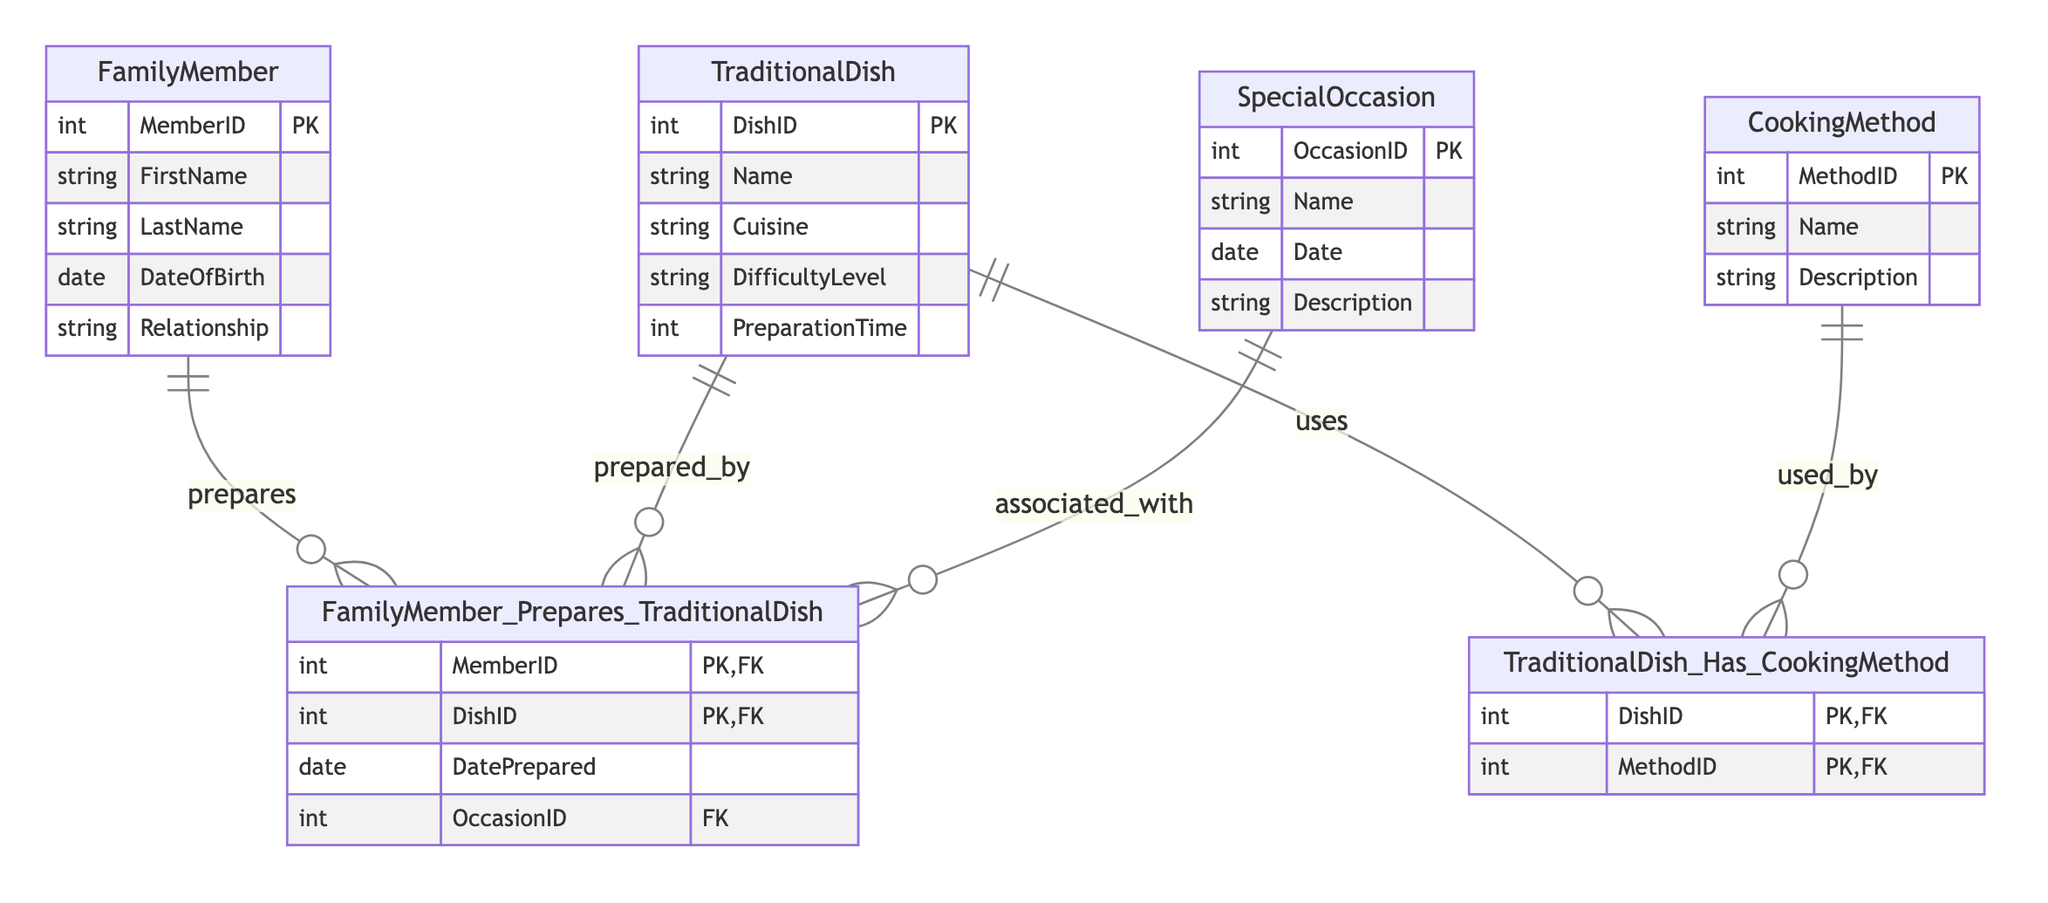What are the entities present in the diagram? The diagram contains the following entities: FamilyMember, TraditionalDish, CookingMethod, and SpecialOccasion. Each of these represents a distinct entity that comprises various attributes to describe their characteristics.
Answer: FamilyMember, TraditionalDish, CookingMethod, SpecialOccasion How many primary keys are defined for FamilyMember? The FamilyMember entity has one primary key, which is MemberID. Primary keys uniquely identify each record within an entity, and in this case, MemberID serves that purpose for FamilyMember.
Answer: 1 Which entity is associated with the SpecialOccasion relationship? The SpecialOccasion relationship is associated with the FamilyMember_Prepares_TraditionalDish entity. The diagram indicates a connection where family members prepare dishes for special occasions, linking the two entities.
Answer: FamilyMember_Prepares_TraditionalDish What is the relationship between TraditionalDish and CookingMethod? The TraditionalDish and CookingMethod entities share a relationship named TraditionalDish_Has_CookingMethod. This relationship signifies that a traditional dish can utilize multiple cooking methods, creating a link between the two entities.
Answer: TraditionalDish_Has_CookingMethod What attribute connects FamilyMember to the prepared dish in the diagram? The attribute that connects FamilyMember to the prepared dish is MemberID. In the FamilyMember_Prepares_TraditionalDish relationship, MemberID serves as a foreign key that links to the MemberID in the FamilyMember entity.
Answer: MemberID Which entity has a description attribute? The CookingMethod entity has a description attribute which provides information about the particular cooking method's details. This attribute allows users to understand the method better, complementing its name.
Answer: CookingMethod How many relationships exist between TraditionalDish and FamilyMember? There exists one relationship between TraditionalDish and FamilyMember, specifically named FamilyMember_Prepares_TraditionalDish. This relationship captures the association of family members with the dishes they prepare.
Answer: 1 Which entity has an attribute for preparation time? The TraditionalDish entity includes an attribute for preparation time that indicates how long it takes to prepare a certain dish. This is an important factor for cooks when planning meal preparation.
Answer: TraditionalDish What is the primary key for the TraditionalDish entity? The primary key for the TraditionalDish entity is DishID. This identifier is crucial for uniquely distinguishing each dish in the TraditionalDish entity, ensuring no two dishes share the same ID.
Answer: DishID 